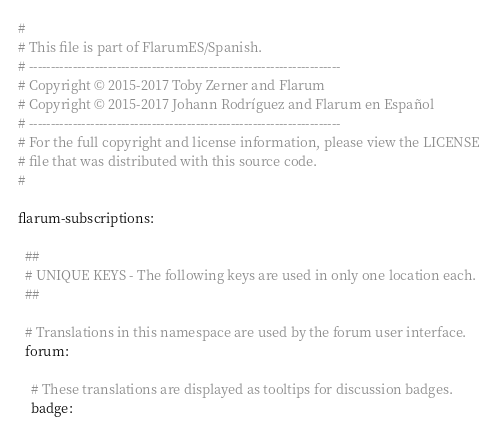<code> <loc_0><loc_0><loc_500><loc_500><_YAML_>#
# This file is part of FlarumES/Spanish.
# -----------------------------------------------------------------------
# Copyright © 2015-2017 Toby Zerner and Flarum
# Copyright © 2015-2017 Johann Rodríguez and Flarum en Español
# -----------------------------------------------------------------------
# For the full copyright and license information, please view the LICENSE
# file that was distributed with this source code.
#

flarum-subscriptions:

  ##
  # UNIQUE KEYS - The following keys are used in only one location each.
  ##

  # Translations in this namespace are used by the forum user interface.
  forum:

    # These translations are displayed as tooltips for discussion badges.
    badge:</code> 